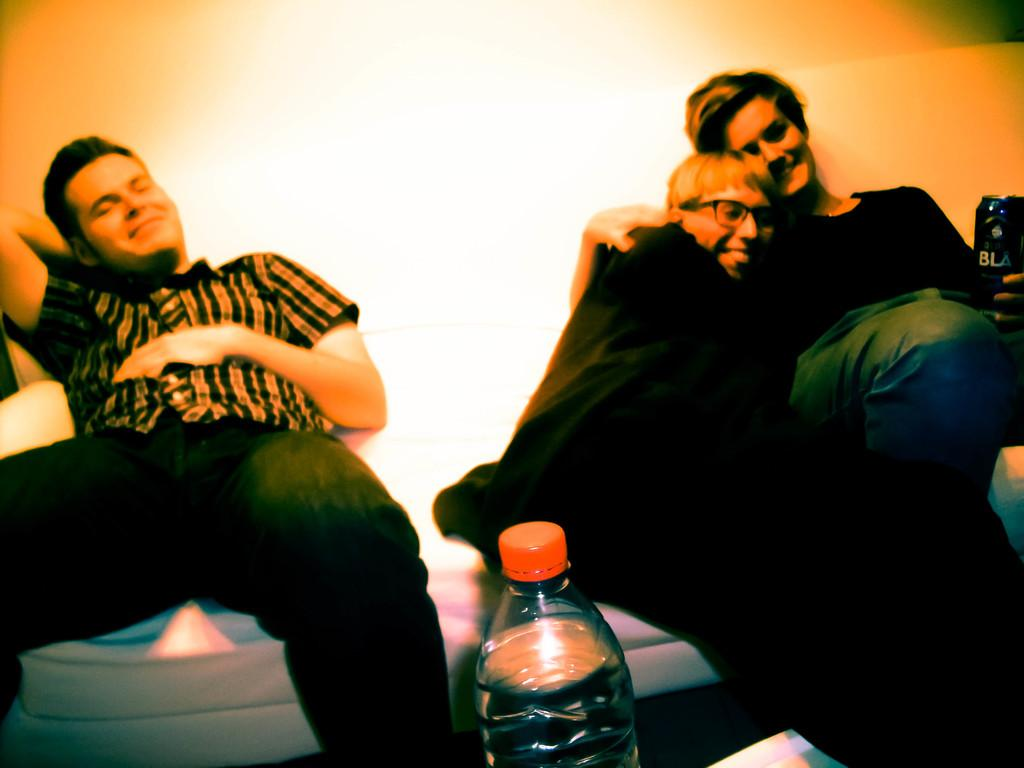How many people are present in the image? There are three people in the image. What are the people doing in the image? The people are sitting on a sofa. What is one person holding in the image? One person is holding a tin. What other furniture is visible in the image? There is a table in the image. What is on the table in the image? There is a bottle on the table. What type of friction can be observed between the sofa and the people sitting on it? There is no information about friction between the sofa and the people in the image. How does the bottle on the table affect the stomach of the people in the image? There is no information about the stomachs of the people or the effect of the bottle in the image. 